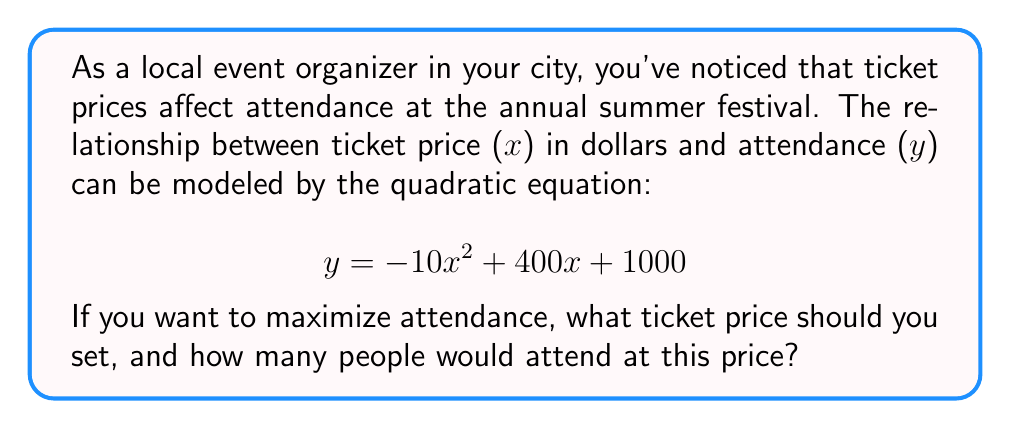Teach me how to tackle this problem. To find the maximum attendance and corresponding ticket price, we need to follow these steps:

1) The quadratic equation given is in the form $y = ax^2 + bx + c$, where:
   $a = -10$, $b = 400$, and $c = 1000$

2) For a quadratic function, the x-coordinate of the vertex represents the value that maximizes (or minimizes) the function. The formula for this x-coordinate is:

   $$ x = -\frac{b}{2a} $$

3) Substituting our values:

   $$ x = -\frac{400}{2(-10)} = -\frac{400}{-20} = 20 $$

4) This means the optimal ticket price is $20.

5) To find the maximum attendance, we substitute x = 20 into our original equation:

   $$ y = -10(20)^2 + 400(20) + 1000 $$
   $$ y = -10(400) + 8000 + 1000 $$
   $$ y = -4000 + 8000 + 1000 $$
   $$ y = 5000 $$

Therefore, the maximum attendance is 5000 people.
Answer: $20 ticket price; 5000 attendees 